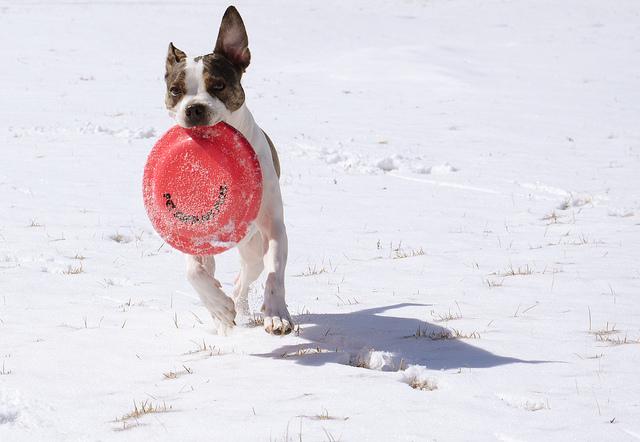Is the dog carrying a frisbee?
Give a very brief answer. Yes. What image is on the frisbee?
Keep it brief. Words. Approximately how deep is the snow?
Be succinct. 1 inch. 